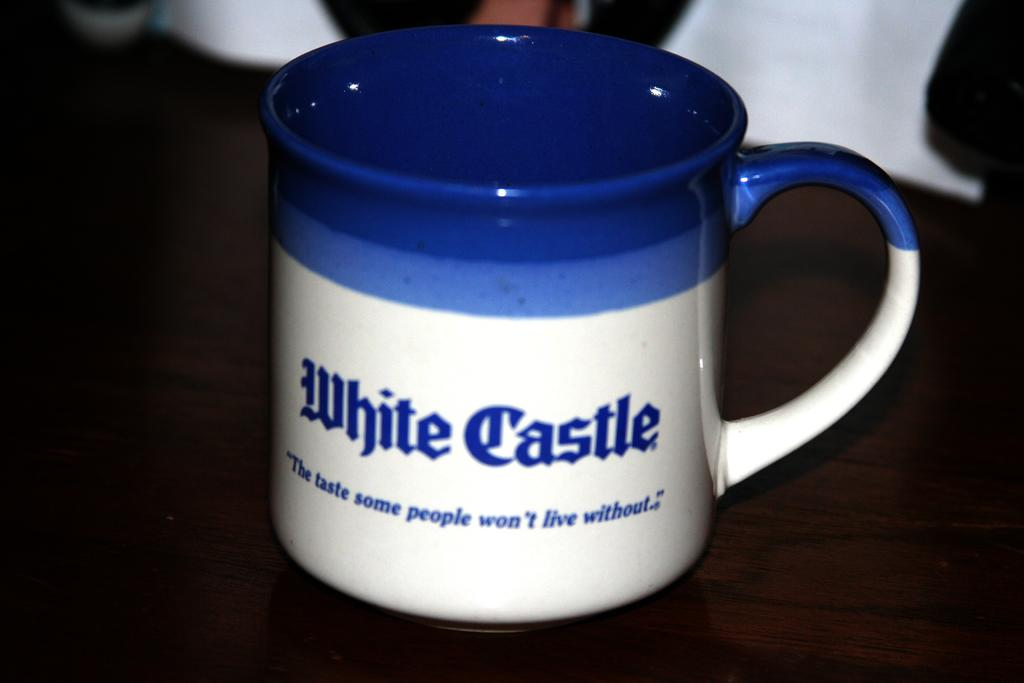Provide a one-sentence caption for the provided image. a coffee cuo from the business white castle. 